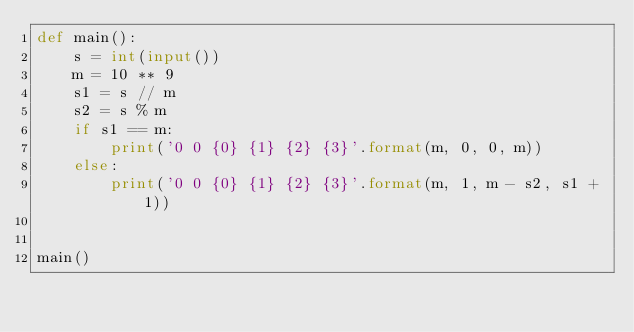Convert code to text. <code><loc_0><loc_0><loc_500><loc_500><_Python_>def main():
    s = int(input())
    m = 10 ** 9
    s1 = s // m
    s2 = s % m
    if s1 == m:
        print('0 0 {0} {1} {2} {3}'.format(m, 0, 0, m))
    else:
        print('0 0 {0} {1} {2} {3}'.format(m, 1, m - s2, s1 + 1))


main()
</code> 